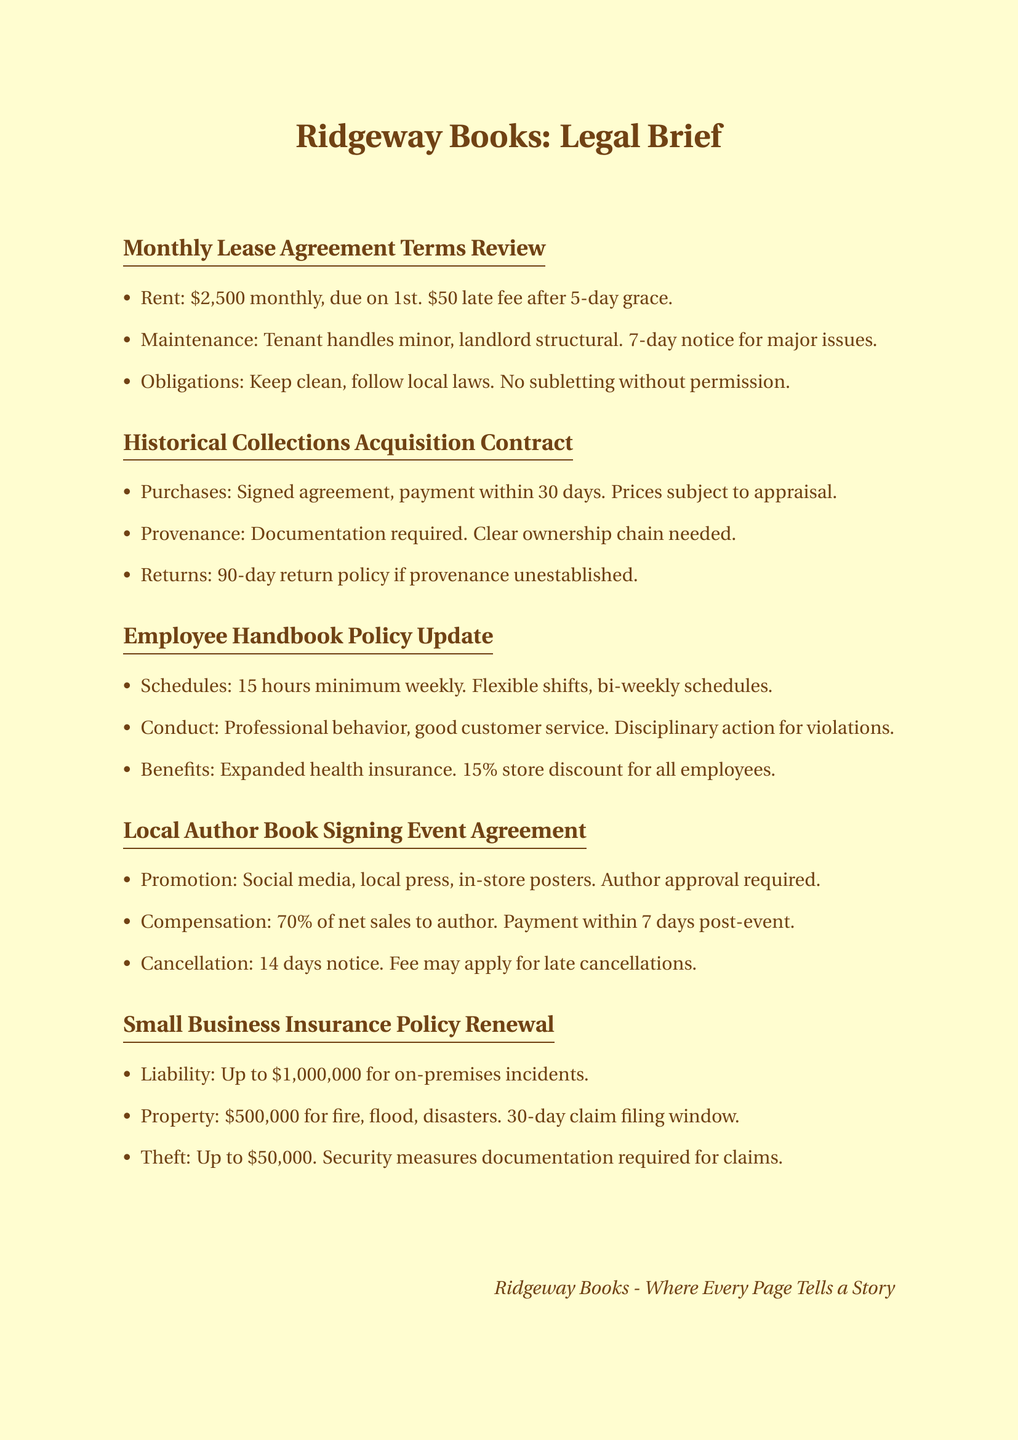What is the monthly rent for Ridgeway Books? The monthly rent is specified in the lease agreement section of the document as $2,500.
Answer: $2,500 How many days does the tenant have to provide notice for major maintenance issues? The document states that the tenant must provide 7 days' notice for major maintenance issues.
Answer: 7 days What percentage of net sales does the author receive at the book signing event? The agreement outlines that the author receives 70% of net sales from the event.
Answer: 70% What is the return policy duration for acquisitions of historical collections? The policy indicates a 90-day return period for items if provenance is not established.
Answer: 90 days What is the total liability coverage available under the insurance policy? The document mentions that the liability coverage is up to $1,000,000 for on-premises incidents.
Answer: $1,000,000 What is the minimum required weekly work hours for employees? The employee handbook specifies a minimum of 15 weekly hours for employees.
Answer: 15 hours How long is the claim filing window for property damage? The insurance policy renewal section states a 30-day claim filing window for property damage.
Answer: 30 days What must be documented to claim theft protection under the insurance policy? The document requires security measures documentation to be provided for theft protection claims.
Answer: Security measures documentation What action may be taken for violations of the employee code of conduct? The handbook mentions that disciplinary action may be taken for violations of the code of conduct.
Answer: Disciplinary action 